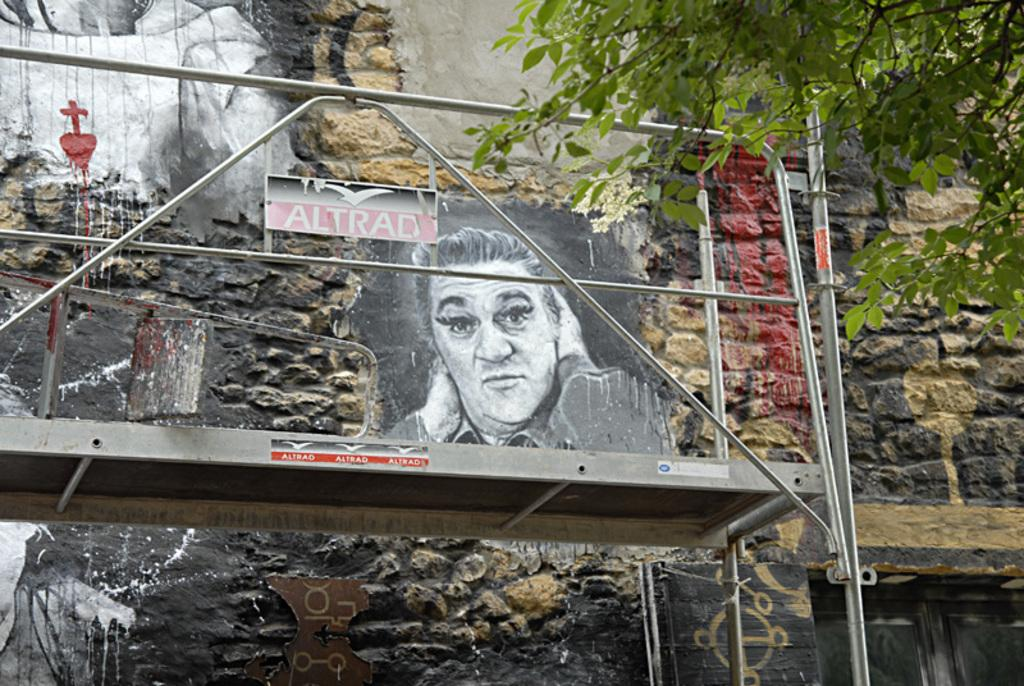What type of structure is in the image? There is a building in the image. What feature of the building is mentioned in the facts? The building has a door. Are there any decorative elements on the building? Yes, there is a painting on the building wall. What material is visible in the image? Metal rods are visible in the image. What type of natural element is in the image? There is a tree in the image. What type of jewel is hanging from the tree in the image? There is no jewel hanging from the tree in the image; it only contains a tree and other elements mentioned in the facts. 